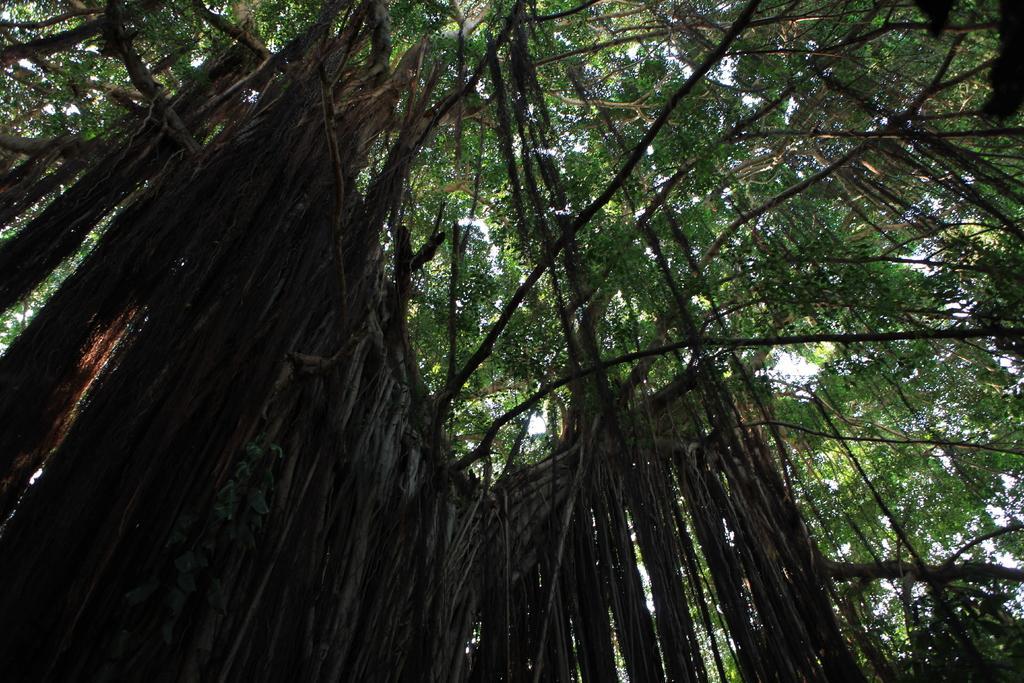How would you summarize this image in a sentence or two? In this picture I can see trees, and in the background there is the sky. 